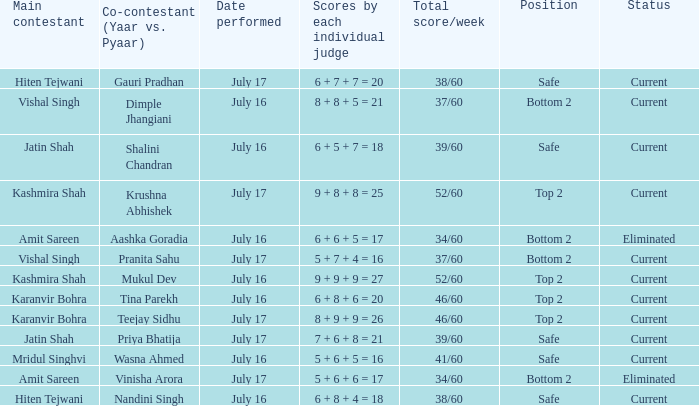What date did Jatin Shah and Shalini Chandran perform? July 16. 